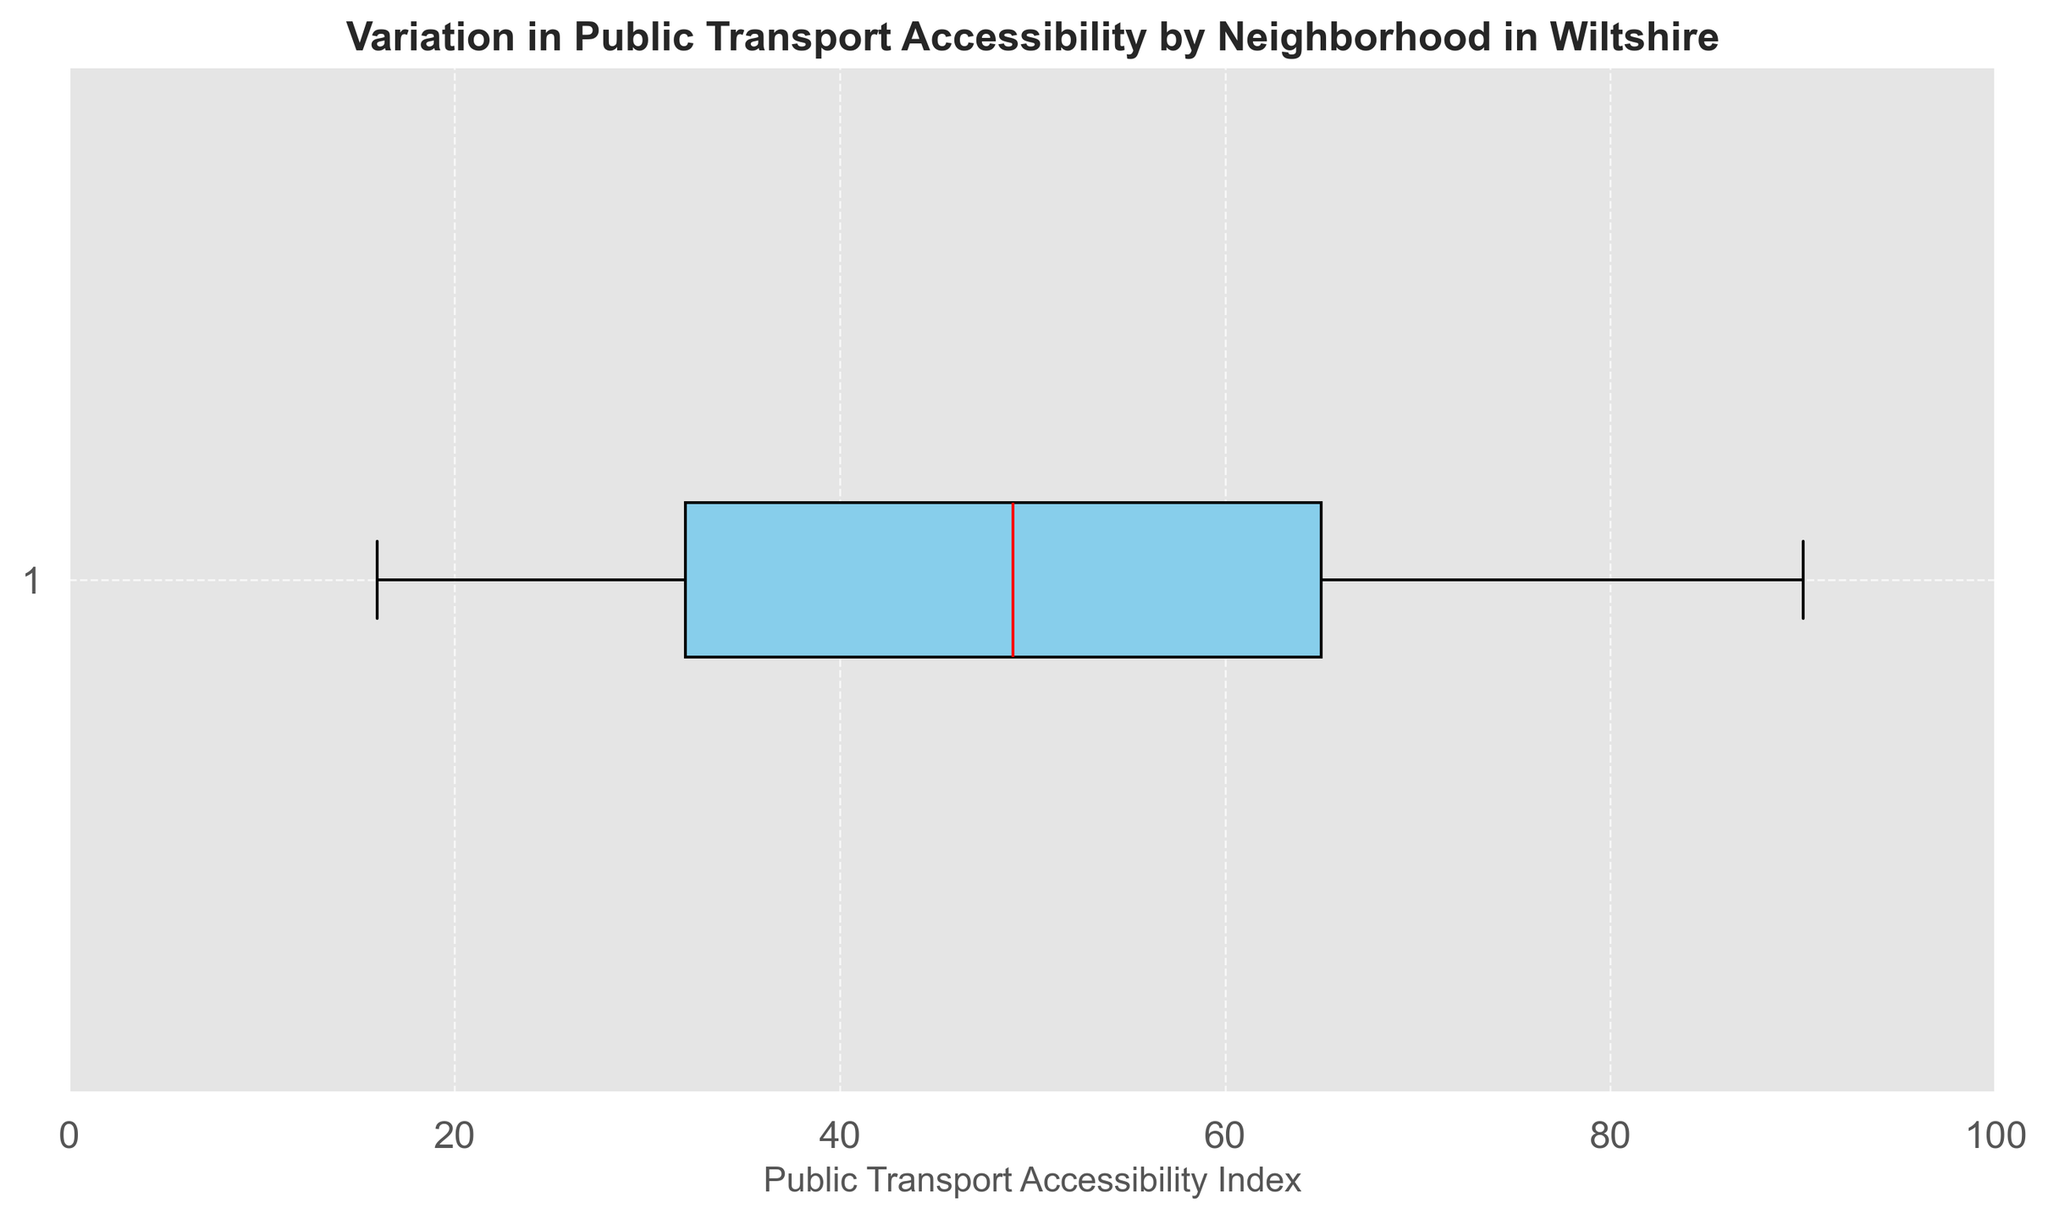What's the median value of the Public Transport Accessibility Index? The median value is represented by the red line within the box in the box plot. By observing the figure, the red line appears around 55.
Answer: 55 What's the interquartile range (IQR) of the Public Transport Accessibility Index? The IQR is calculated as the difference between the third quartile (Q3) and the first quartile (Q1). In the box plot, the top and bottom edges of the box represent Q3 and Q1, respectively. From the plot, Q1 is around 38, and Q3 is around 72. Thus, the IQR is 72 - 38 = 34.
Answer: 34 What is the range of Public Transport Accessibility Index in Wiltshire? The range is the difference between the maximum and minimum values represented by the ends of the whiskers in the box plot. From the plot, the minimum value is about 16 and the maximum is about 90. The range is 90 - 16 = 74.
Answer: 74 Are there any outliers in the dataset? In a box plot, outliers are typically indicated by individual points that lie outside the whiskers. Observing the figure, there are no individual points outside the whiskers, indicating there are no outliers.
Answer: No Which neighborhood has the highest Public Transport Accessibility Index? The highest value on the box plot is around 90, which corresponds to Swindon, as indicated by the dataset.
Answer: Swindon Which neighborhood has the lowest Public Transport Accessibility Index? The lowest value on the box plot is around 16, which corresponds to Zeals, as indicated by the dataset.
Answer: Zeals How is the spread of the lower half of the dataset compared to the upper half? The spread of the lower half (Q1 to the minimum) and the upper half (Q3 to the maximum) can be compared by observing the lengths of each segment. The lower half whisker is longer than the upper half whisker, indicating more variation in the lower values.
Answer: More variation in the lower half Does the dataset exhibit a symmetric distribution? A symmetric distribution would have the median centered within the interquartile range and the whiskers of equal length. Observing the box plot, the median is not exactly centered, and the whiskers are not of equal length, indicating a skewed distribution.
Answer: No 